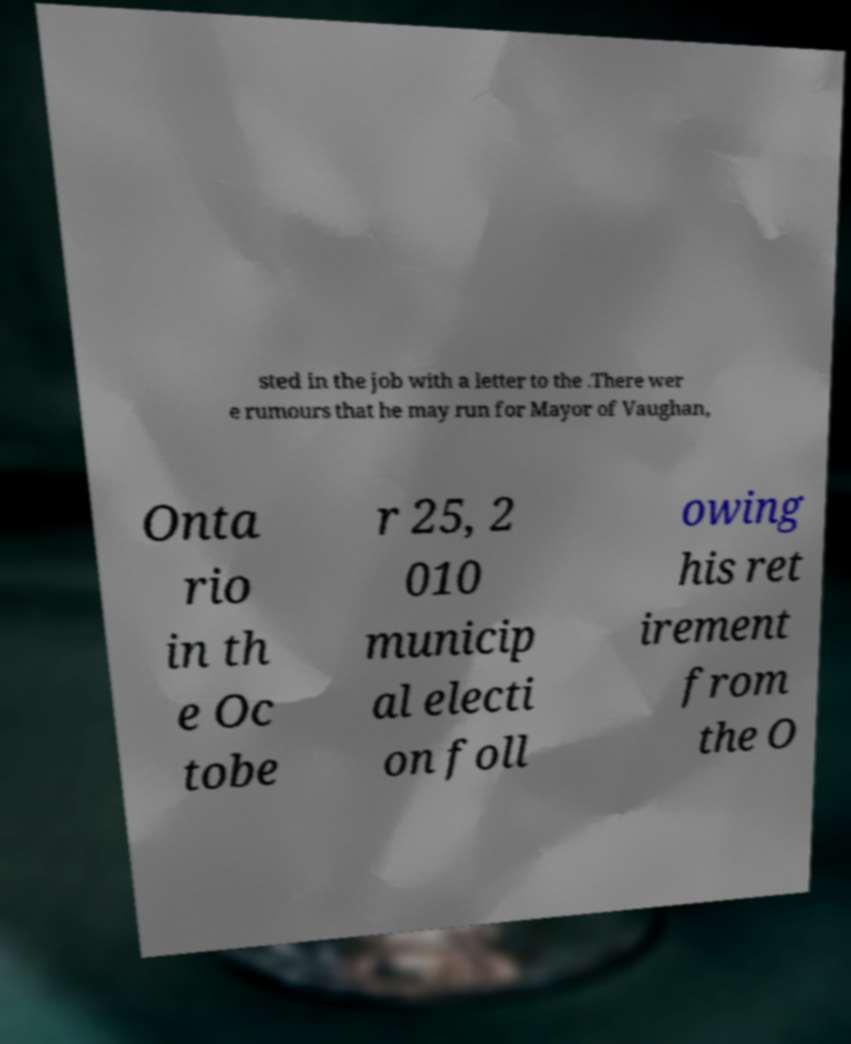What messages or text are displayed in this image? I need them in a readable, typed format. sted in the job with a letter to the .There wer e rumours that he may run for Mayor of Vaughan, Onta rio in th e Oc tobe r 25, 2 010 municip al electi on foll owing his ret irement from the O 